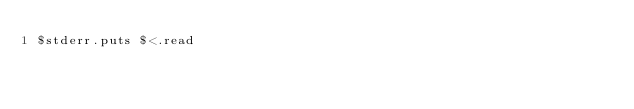<code> <loc_0><loc_0><loc_500><loc_500><_Ruby_>$stderr.puts $<.read</code> 